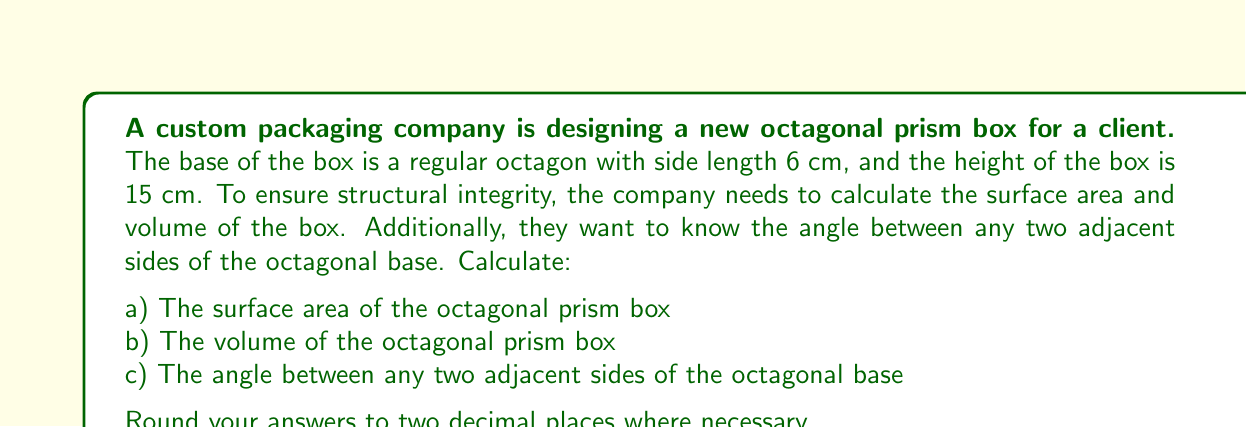Can you answer this question? Let's approach this problem step by step:

1) For a regular octagon:
   - Number of sides, $n = 8$
   - Side length, $s = 6$ cm

2) To calculate the surface area and volume, we need the area of the base:
   - Area of a regular octagon: $A = 2a^2(1+\sqrt{2})$, where $a$ is the apothem
   - Apothem: $a = \frac{s}{2\tan(\frac{\pi}{n})} = \frac{6}{2\tan(\frac{\pi}{8})} = 7.25$ cm
   - Base area: $A = 2(7.25)^2(1+\sqrt{2}) = 277.13$ cm²

3) Surface area calculation:
   - Lateral surface area = Perimeter of base × Height
   - Perimeter of base = $8 \times 6 = 48$ cm
   - Lateral surface area = $48 \times 15 = 720$ cm²
   - Total surface area = Lateral surface area + 2 × Base area
   - Total surface area = $720 + 2(277.13) = 1274.26$ cm²

4) Volume calculation:
   - Volume = Base area × Height
   - Volume = $277.13 \times 15 = 4156.95$ cm³

5) Angle between adjacent sides:
   - In a regular octagon, the interior angle sum is $(n-2) \times 180°$
   - Each interior angle = $\frac{(8-2) \times 180°}{8} = 135°$

Therefore:
a) Surface area ≈ 1274.26 cm²
b) Volume ≈ 4156.95 cm³
c) Angle between adjacent sides = 135°
Answer: a) 1274.26 cm²
b) 4156.95 cm³
c) 135° 